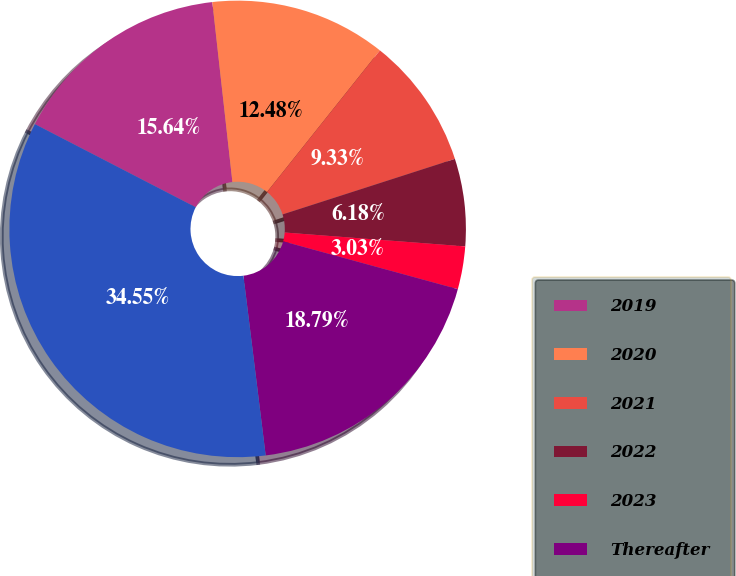<chart> <loc_0><loc_0><loc_500><loc_500><pie_chart><fcel>2019<fcel>2020<fcel>2021<fcel>2022<fcel>2023<fcel>Thereafter<fcel>Total<nl><fcel>15.64%<fcel>12.48%<fcel>9.33%<fcel>6.18%<fcel>3.03%<fcel>18.79%<fcel>34.55%<nl></chart> 